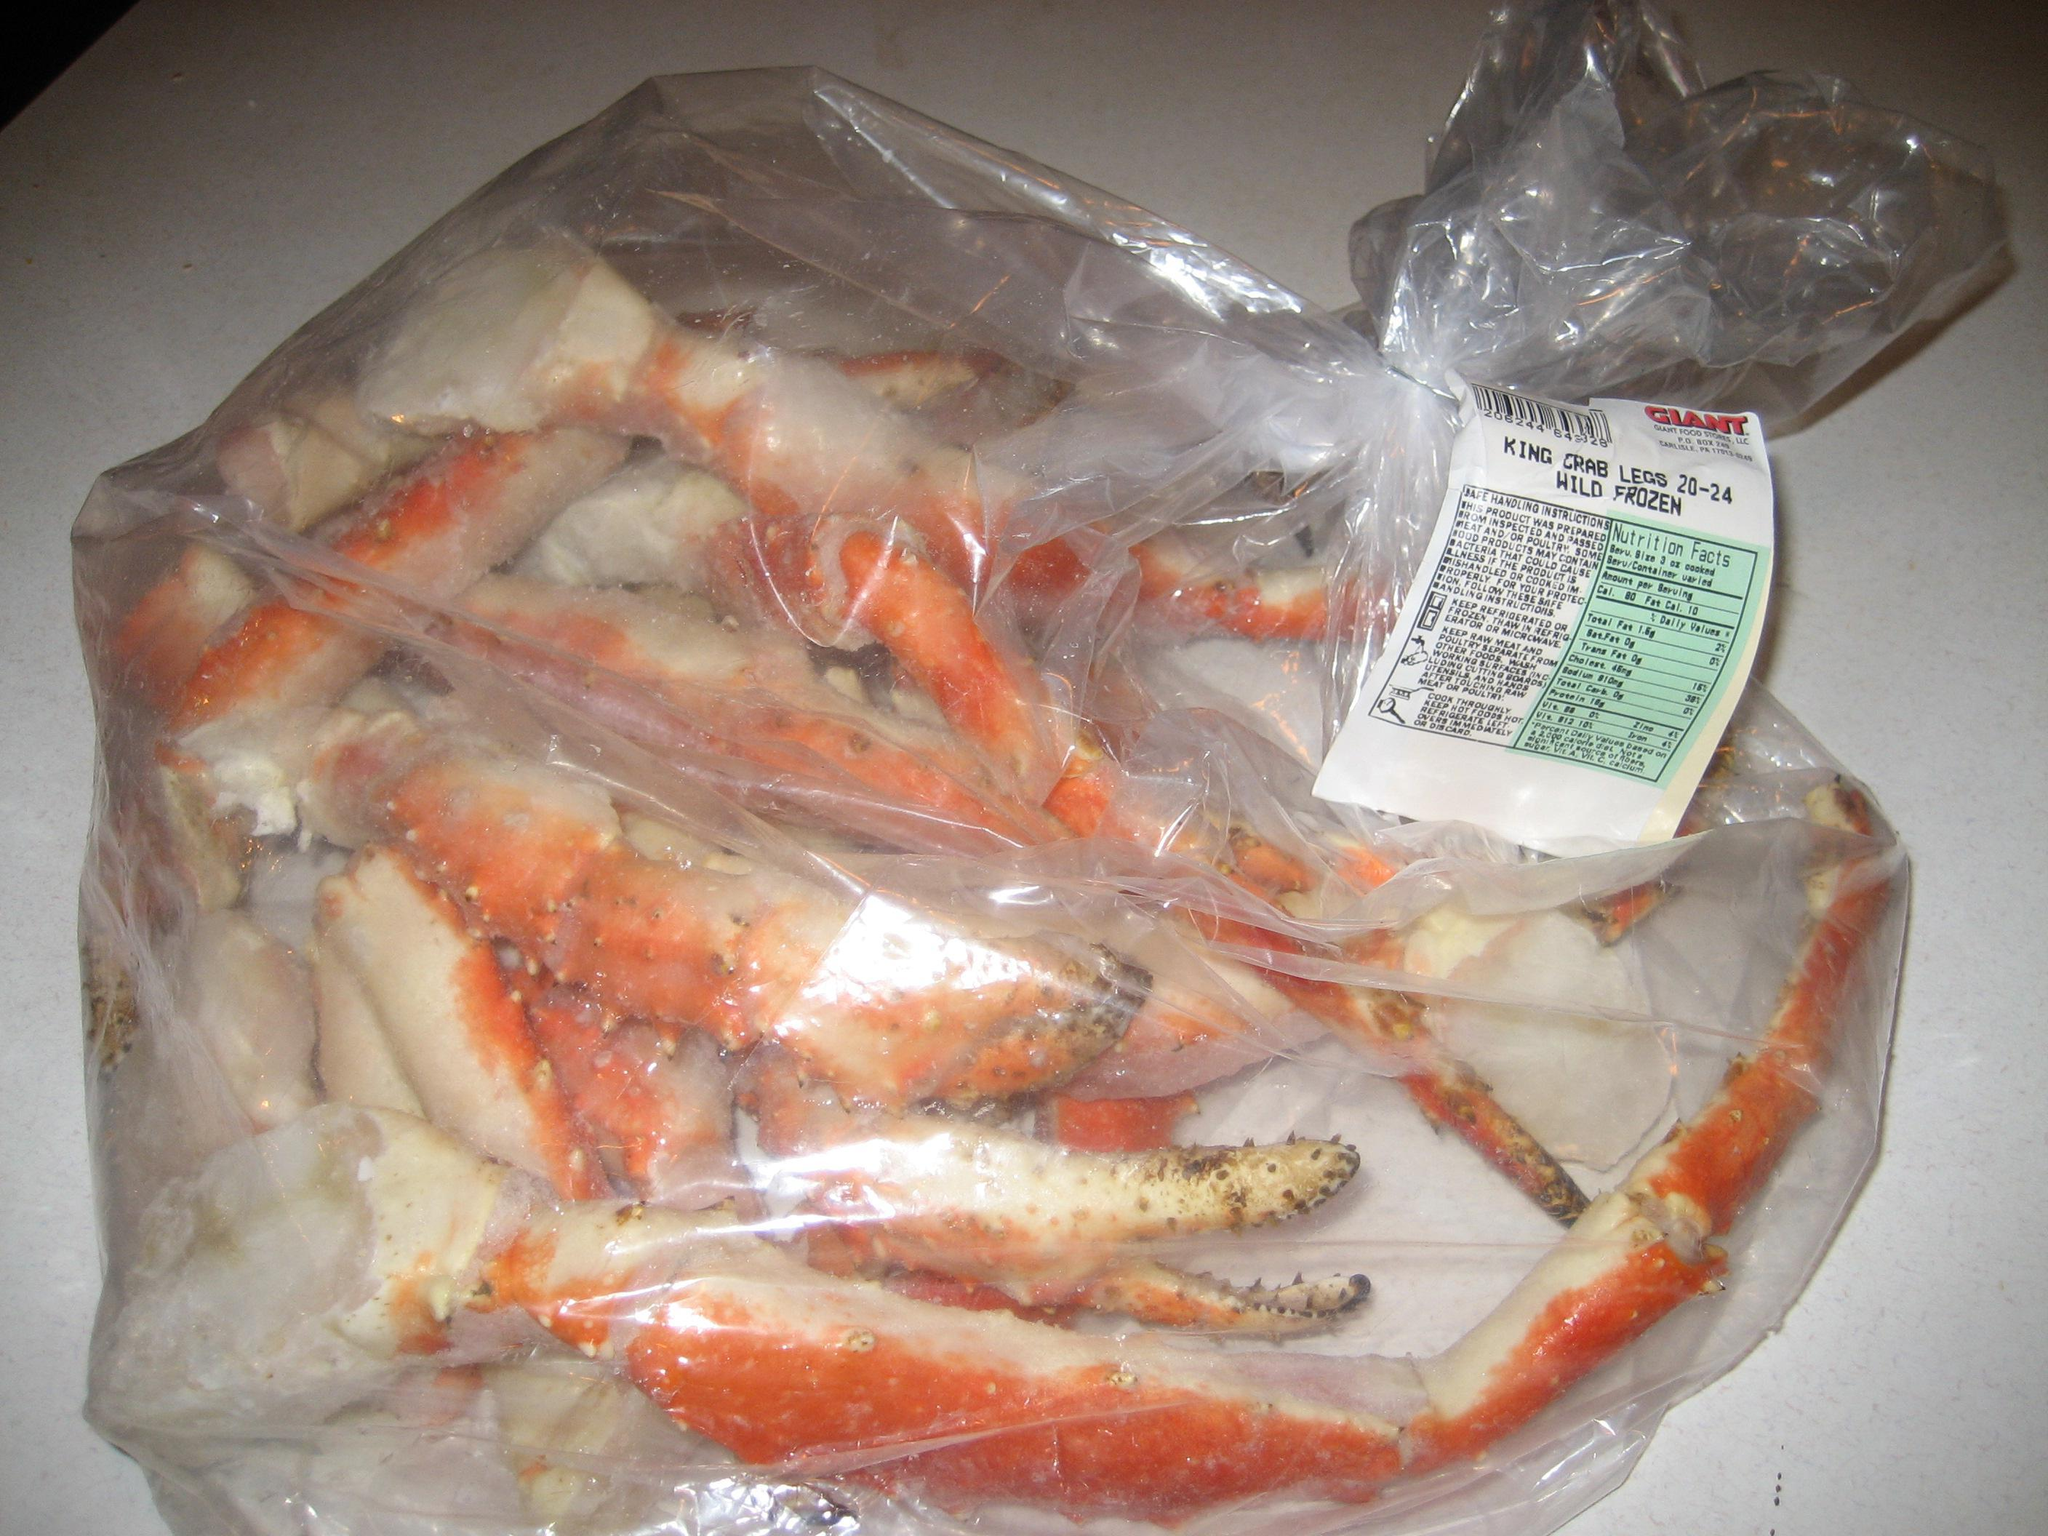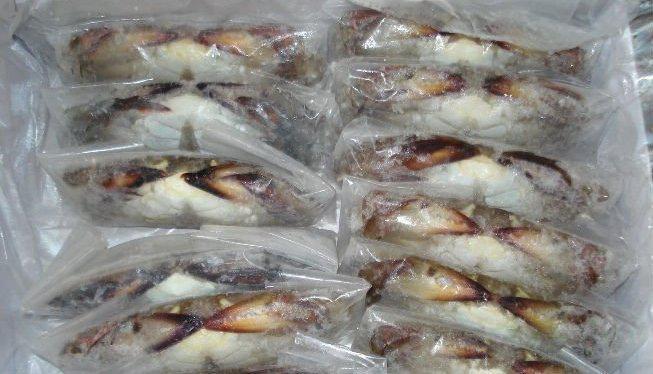The first image is the image on the left, the second image is the image on the right. Given the left and right images, does the statement "The left image shows one clear plastic wrapper surrounding red-orange crab claws, and the right image shows multiple individually plastic wrapped crabs." hold true? Answer yes or no. Yes. The first image is the image on the left, the second image is the image on the right. For the images displayed, is the sentence "A ruler depicts the size of a crab." factually correct? Answer yes or no. No. 